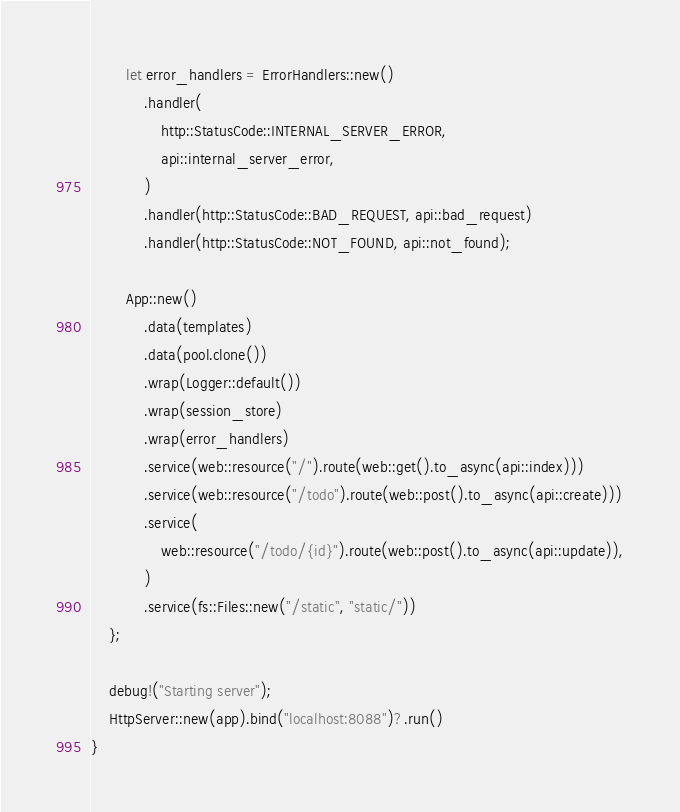Convert code to text. <code><loc_0><loc_0><loc_500><loc_500><_Rust_>        let error_handlers = ErrorHandlers::new()
            .handler(
                http::StatusCode::INTERNAL_SERVER_ERROR,
                api::internal_server_error,
            )
            .handler(http::StatusCode::BAD_REQUEST, api::bad_request)
            .handler(http::StatusCode::NOT_FOUND, api::not_found);

        App::new()
            .data(templates)
            .data(pool.clone())
            .wrap(Logger::default())
            .wrap(session_store)
            .wrap(error_handlers)
            .service(web::resource("/").route(web::get().to_async(api::index)))
            .service(web::resource("/todo").route(web::post().to_async(api::create)))
            .service(
                web::resource("/todo/{id}").route(web::post().to_async(api::update)),
            )
            .service(fs::Files::new("/static", "static/"))
    };

    debug!("Starting server");
    HttpServer::new(app).bind("localhost:8088")?.run()
}
</code> 